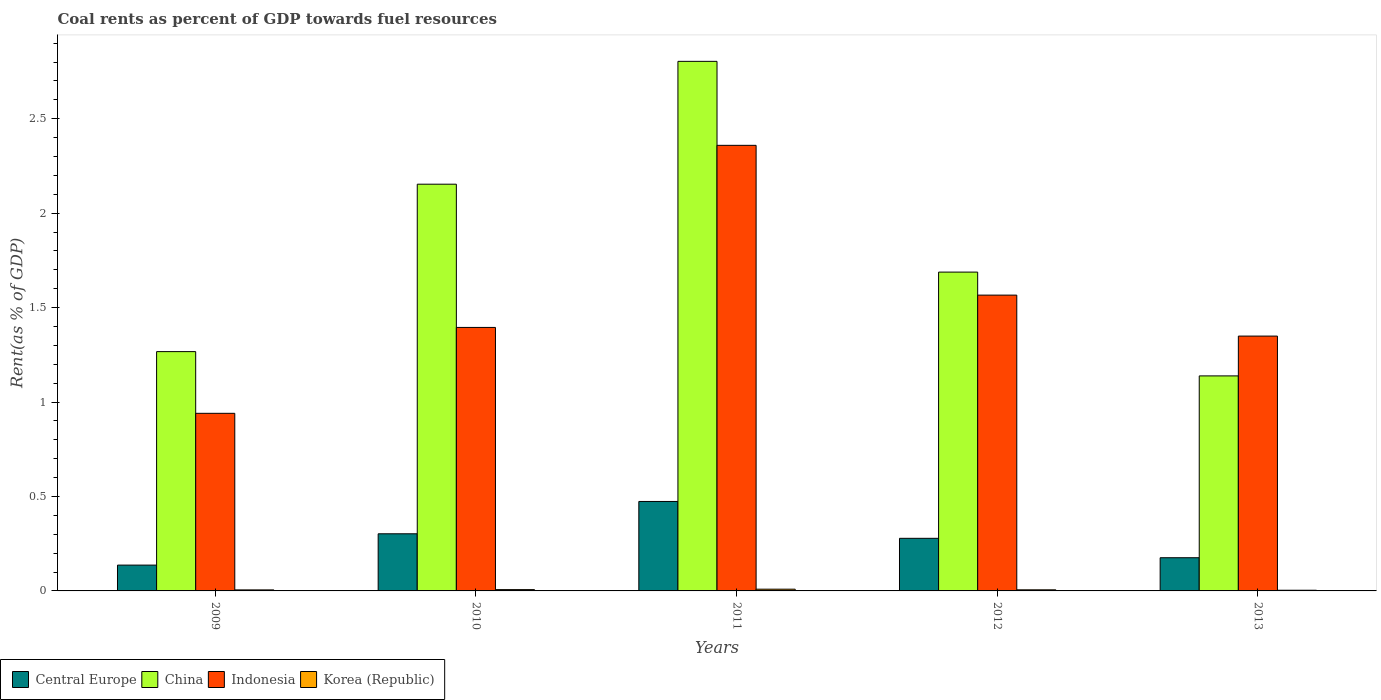How many different coloured bars are there?
Make the answer very short. 4. Are the number of bars per tick equal to the number of legend labels?
Offer a very short reply. Yes. How many bars are there on the 1st tick from the right?
Make the answer very short. 4. What is the label of the 1st group of bars from the left?
Provide a succinct answer. 2009. What is the coal rent in Indonesia in 2013?
Offer a very short reply. 1.35. Across all years, what is the maximum coal rent in China?
Your answer should be compact. 2.8. Across all years, what is the minimum coal rent in Indonesia?
Make the answer very short. 0.94. In which year was the coal rent in Indonesia minimum?
Make the answer very short. 2009. What is the total coal rent in China in the graph?
Offer a terse response. 9.05. What is the difference between the coal rent in Korea (Republic) in 2009 and that in 2013?
Your response must be concise. 0. What is the difference between the coal rent in China in 2010 and the coal rent in Korea (Republic) in 2013?
Make the answer very short. 2.15. What is the average coal rent in Indonesia per year?
Make the answer very short. 1.52. In the year 2010, what is the difference between the coal rent in China and coal rent in Korea (Republic)?
Offer a very short reply. 2.15. In how many years, is the coal rent in China greater than 1.1 %?
Your answer should be compact. 5. What is the ratio of the coal rent in Central Europe in 2011 to that in 2012?
Make the answer very short. 1.7. Is the coal rent in Central Europe in 2009 less than that in 2011?
Make the answer very short. Yes. What is the difference between the highest and the second highest coal rent in China?
Keep it short and to the point. 0.65. What is the difference between the highest and the lowest coal rent in Central Europe?
Give a very brief answer. 0.34. Is the sum of the coal rent in Indonesia in 2010 and 2012 greater than the maximum coal rent in Central Europe across all years?
Provide a short and direct response. Yes. Is it the case that in every year, the sum of the coal rent in Indonesia and coal rent in China is greater than the sum of coal rent in Korea (Republic) and coal rent in Central Europe?
Offer a terse response. Yes. What does the 2nd bar from the right in 2012 represents?
Give a very brief answer. Indonesia. Is it the case that in every year, the sum of the coal rent in Central Europe and coal rent in Korea (Republic) is greater than the coal rent in China?
Offer a very short reply. No. Are all the bars in the graph horizontal?
Your response must be concise. No. What is the difference between two consecutive major ticks on the Y-axis?
Offer a very short reply. 0.5. Are the values on the major ticks of Y-axis written in scientific E-notation?
Ensure brevity in your answer.  No. Does the graph contain grids?
Provide a short and direct response. No. Where does the legend appear in the graph?
Give a very brief answer. Bottom left. How many legend labels are there?
Make the answer very short. 4. How are the legend labels stacked?
Keep it short and to the point. Horizontal. What is the title of the graph?
Your answer should be compact. Coal rents as percent of GDP towards fuel resources. What is the label or title of the X-axis?
Your answer should be compact. Years. What is the label or title of the Y-axis?
Provide a short and direct response. Rent(as % of GDP). What is the Rent(as % of GDP) in Central Europe in 2009?
Provide a short and direct response. 0.14. What is the Rent(as % of GDP) in China in 2009?
Make the answer very short. 1.27. What is the Rent(as % of GDP) of Indonesia in 2009?
Keep it short and to the point. 0.94. What is the Rent(as % of GDP) in Korea (Republic) in 2009?
Give a very brief answer. 0.01. What is the Rent(as % of GDP) in Central Europe in 2010?
Provide a succinct answer. 0.3. What is the Rent(as % of GDP) of China in 2010?
Keep it short and to the point. 2.15. What is the Rent(as % of GDP) of Indonesia in 2010?
Offer a very short reply. 1.39. What is the Rent(as % of GDP) of Korea (Republic) in 2010?
Ensure brevity in your answer.  0.01. What is the Rent(as % of GDP) of Central Europe in 2011?
Offer a terse response. 0.47. What is the Rent(as % of GDP) in China in 2011?
Offer a very short reply. 2.8. What is the Rent(as % of GDP) in Indonesia in 2011?
Your answer should be compact. 2.36. What is the Rent(as % of GDP) in Korea (Republic) in 2011?
Your response must be concise. 0.01. What is the Rent(as % of GDP) of Central Europe in 2012?
Your response must be concise. 0.28. What is the Rent(as % of GDP) of China in 2012?
Offer a very short reply. 1.69. What is the Rent(as % of GDP) of Indonesia in 2012?
Provide a short and direct response. 1.57. What is the Rent(as % of GDP) of Korea (Republic) in 2012?
Provide a succinct answer. 0.01. What is the Rent(as % of GDP) in Central Europe in 2013?
Ensure brevity in your answer.  0.18. What is the Rent(as % of GDP) in China in 2013?
Make the answer very short. 1.14. What is the Rent(as % of GDP) of Indonesia in 2013?
Your answer should be compact. 1.35. What is the Rent(as % of GDP) of Korea (Republic) in 2013?
Provide a succinct answer. 0. Across all years, what is the maximum Rent(as % of GDP) in Central Europe?
Your answer should be very brief. 0.47. Across all years, what is the maximum Rent(as % of GDP) in China?
Provide a short and direct response. 2.8. Across all years, what is the maximum Rent(as % of GDP) of Indonesia?
Offer a very short reply. 2.36. Across all years, what is the maximum Rent(as % of GDP) in Korea (Republic)?
Provide a succinct answer. 0.01. Across all years, what is the minimum Rent(as % of GDP) in Central Europe?
Offer a very short reply. 0.14. Across all years, what is the minimum Rent(as % of GDP) of China?
Keep it short and to the point. 1.14. Across all years, what is the minimum Rent(as % of GDP) in Indonesia?
Make the answer very short. 0.94. Across all years, what is the minimum Rent(as % of GDP) in Korea (Republic)?
Your answer should be compact. 0. What is the total Rent(as % of GDP) in Central Europe in the graph?
Keep it short and to the point. 1.37. What is the total Rent(as % of GDP) of China in the graph?
Provide a succinct answer. 9.05. What is the total Rent(as % of GDP) in Indonesia in the graph?
Provide a succinct answer. 7.61. What is the total Rent(as % of GDP) of Korea (Republic) in the graph?
Provide a short and direct response. 0.03. What is the difference between the Rent(as % of GDP) in Central Europe in 2009 and that in 2010?
Keep it short and to the point. -0.17. What is the difference between the Rent(as % of GDP) of China in 2009 and that in 2010?
Provide a short and direct response. -0.89. What is the difference between the Rent(as % of GDP) in Indonesia in 2009 and that in 2010?
Give a very brief answer. -0.45. What is the difference between the Rent(as % of GDP) of Korea (Republic) in 2009 and that in 2010?
Provide a succinct answer. -0. What is the difference between the Rent(as % of GDP) of Central Europe in 2009 and that in 2011?
Your response must be concise. -0.34. What is the difference between the Rent(as % of GDP) in China in 2009 and that in 2011?
Your answer should be very brief. -1.54. What is the difference between the Rent(as % of GDP) of Indonesia in 2009 and that in 2011?
Make the answer very short. -1.42. What is the difference between the Rent(as % of GDP) in Korea (Republic) in 2009 and that in 2011?
Your answer should be very brief. -0. What is the difference between the Rent(as % of GDP) in Central Europe in 2009 and that in 2012?
Provide a succinct answer. -0.14. What is the difference between the Rent(as % of GDP) of China in 2009 and that in 2012?
Your answer should be compact. -0.42. What is the difference between the Rent(as % of GDP) of Indonesia in 2009 and that in 2012?
Make the answer very short. -0.63. What is the difference between the Rent(as % of GDP) of Korea (Republic) in 2009 and that in 2012?
Offer a terse response. -0. What is the difference between the Rent(as % of GDP) of Central Europe in 2009 and that in 2013?
Your answer should be very brief. -0.04. What is the difference between the Rent(as % of GDP) in China in 2009 and that in 2013?
Ensure brevity in your answer.  0.13. What is the difference between the Rent(as % of GDP) in Indonesia in 2009 and that in 2013?
Keep it short and to the point. -0.41. What is the difference between the Rent(as % of GDP) of Korea (Republic) in 2009 and that in 2013?
Offer a very short reply. 0. What is the difference between the Rent(as % of GDP) in Central Europe in 2010 and that in 2011?
Provide a short and direct response. -0.17. What is the difference between the Rent(as % of GDP) of China in 2010 and that in 2011?
Offer a very short reply. -0.65. What is the difference between the Rent(as % of GDP) in Indonesia in 2010 and that in 2011?
Your answer should be compact. -0.96. What is the difference between the Rent(as % of GDP) in Korea (Republic) in 2010 and that in 2011?
Your answer should be compact. -0. What is the difference between the Rent(as % of GDP) in Central Europe in 2010 and that in 2012?
Make the answer very short. 0.02. What is the difference between the Rent(as % of GDP) of China in 2010 and that in 2012?
Offer a very short reply. 0.47. What is the difference between the Rent(as % of GDP) in Indonesia in 2010 and that in 2012?
Ensure brevity in your answer.  -0.17. What is the difference between the Rent(as % of GDP) in Korea (Republic) in 2010 and that in 2012?
Provide a succinct answer. 0. What is the difference between the Rent(as % of GDP) in Central Europe in 2010 and that in 2013?
Offer a terse response. 0.13. What is the difference between the Rent(as % of GDP) in China in 2010 and that in 2013?
Give a very brief answer. 1.01. What is the difference between the Rent(as % of GDP) of Indonesia in 2010 and that in 2013?
Keep it short and to the point. 0.05. What is the difference between the Rent(as % of GDP) in Korea (Republic) in 2010 and that in 2013?
Offer a very short reply. 0. What is the difference between the Rent(as % of GDP) in Central Europe in 2011 and that in 2012?
Your response must be concise. 0.2. What is the difference between the Rent(as % of GDP) of China in 2011 and that in 2012?
Ensure brevity in your answer.  1.12. What is the difference between the Rent(as % of GDP) in Indonesia in 2011 and that in 2012?
Provide a succinct answer. 0.79. What is the difference between the Rent(as % of GDP) in Korea (Republic) in 2011 and that in 2012?
Offer a terse response. 0. What is the difference between the Rent(as % of GDP) of Central Europe in 2011 and that in 2013?
Provide a short and direct response. 0.3. What is the difference between the Rent(as % of GDP) of China in 2011 and that in 2013?
Your answer should be compact. 1.67. What is the difference between the Rent(as % of GDP) in Indonesia in 2011 and that in 2013?
Offer a very short reply. 1.01. What is the difference between the Rent(as % of GDP) of Korea (Republic) in 2011 and that in 2013?
Provide a succinct answer. 0.01. What is the difference between the Rent(as % of GDP) in Central Europe in 2012 and that in 2013?
Make the answer very short. 0.1. What is the difference between the Rent(as % of GDP) of China in 2012 and that in 2013?
Provide a short and direct response. 0.55. What is the difference between the Rent(as % of GDP) in Indonesia in 2012 and that in 2013?
Offer a terse response. 0.22. What is the difference between the Rent(as % of GDP) of Korea (Republic) in 2012 and that in 2013?
Make the answer very short. 0. What is the difference between the Rent(as % of GDP) of Central Europe in 2009 and the Rent(as % of GDP) of China in 2010?
Ensure brevity in your answer.  -2.02. What is the difference between the Rent(as % of GDP) in Central Europe in 2009 and the Rent(as % of GDP) in Indonesia in 2010?
Your response must be concise. -1.26. What is the difference between the Rent(as % of GDP) in Central Europe in 2009 and the Rent(as % of GDP) in Korea (Republic) in 2010?
Provide a succinct answer. 0.13. What is the difference between the Rent(as % of GDP) in China in 2009 and the Rent(as % of GDP) in Indonesia in 2010?
Provide a succinct answer. -0.13. What is the difference between the Rent(as % of GDP) of China in 2009 and the Rent(as % of GDP) of Korea (Republic) in 2010?
Your answer should be compact. 1.26. What is the difference between the Rent(as % of GDP) of Indonesia in 2009 and the Rent(as % of GDP) of Korea (Republic) in 2010?
Your response must be concise. 0.93. What is the difference between the Rent(as % of GDP) of Central Europe in 2009 and the Rent(as % of GDP) of China in 2011?
Make the answer very short. -2.67. What is the difference between the Rent(as % of GDP) of Central Europe in 2009 and the Rent(as % of GDP) of Indonesia in 2011?
Keep it short and to the point. -2.22. What is the difference between the Rent(as % of GDP) in Central Europe in 2009 and the Rent(as % of GDP) in Korea (Republic) in 2011?
Your response must be concise. 0.13. What is the difference between the Rent(as % of GDP) in China in 2009 and the Rent(as % of GDP) in Indonesia in 2011?
Your answer should be very brief. -1.09. What is the difference between the Rent(as % of GDP) of China in 2009 and the Rent(as % of GDP) of Korea (Republic) in 2011?
Offer a terse response. 1.26. What is the difference between the Rent(as % of GDP) of Indonesia in 2009 and the Rent(as % of GDP) of Korea (Republic) in 2011?
Give a very brief answer. 0.93. What is the difference between the Rent(as % of GDP) of Central Europe in 2009 and the Rent(as % of GDP) of China in 2012?
Give a very brief answer. -1.55. What is the difference between the Rent(as % of GDP) in Central Europe in 2009 and the Rent(as % of GDP) in Indonesia in 2012?
Keep it short and to the point. -1.43. What is the difference between the Rent(as % of GDP) of Central Europe in 2009 and the Rent(as % of GDP) of Korea (Republic) in 2012?
Your response must be concise. 0.13. What is the difference between the Rent(as % of GDP) in China in 2009 and the Rent(as % of GDP) in Indonesia in 2012?
Ensure brevity in your answer.  -0.3. What is the difference between the Rent(as % of GDP) of China in 2009 and the Rent(as % of GDP) of Korea (Republic) in 2012?
Your answer should be compact. 1.26. What is the difference between the Rent(as % of GDP) of Indonesia in 2009 and the Rent(as % of GDP) of Korea (Republic) in 2012?
Your response must be concise. 0.93. What is the difference between the Rent(as % of GDP) in Central Europe in 2009 and the Rent(as % of GDP) in China in 2013?
Provide a short and direct response. -1. What is the difference between the Rent(as % of GDP) of Central Europe in 2009 and the Rent(as % of GDP) of Indonesia in 2013?
Offer a terse response. -1.21. What is the difference between the Rent(as % of GDP) in Central Europe in 2009 and the Rent(as % of GDP) in Korea (Republic) in 2013?
Your response must be concise. 0.13. What is the difference between the Rent(as % of GDP) in China in 2009 and the Rent(as % of GDP) in Indonesia in 2013?
Provide a short and direct response. -0.08. What is the difference between the Rent(as % of GDP) of China in 2009 and the Rent(as % of GDP) of Korea (Republic) in 2013?
Make the answer very short. 1.26. What is the difference between the Rent(as % of GDP) in Indonesia in 2009 and the Rent(as % of GDP) in Korea (Republic) in 2013?
Offer a terse response. 0.94. What is the difference between the Rent(as % of GDP) of Central Europe in 2010 and the Rent(as % of GDP) of China in 2011?
Your response must be concise. -2.5. What is the difference between the Rent(as % of GDP) of Central Europe in 2010 and the Rent(as % of GDP) of Indonesia in 2011?
Ensure brevity in your answer.  -2.06. What is the difference between the Rent(as % of GDP) in Central Europe in 2010 and the Rent(as % of GDP) in Korea (Republic) in 2011?
Your answer should be very brief. 0.29. What is the difference between the Rent(as % of GDP) of China in 2010 and the Rent(as % of GDP) of Indonesia in 2011?
Make the answer very short. -0.21. What is the difference between the Rent(as % of GDP) of China in 2010 and the Rent(as % of GDP) of Korea (Republic) in 2011?
Your answer should be compact. 2.14. What is the difference between the Rent(as % of GDP) of Indonesia in 2010 and the Rent(as % of GDP) of Korea (Republic) in 2011?
Provide a succinct answer. 1.39. What is the difference between the Rent(as % of GDP) of Central Europe in 2010 and the Rent(as % of GDP) of China in 2012?
Offer a very short reply. -1.39. What is the difference between the Rent(as % of GDP) of Central Europe in 2010 and the Rent(as % of GDP) of Indonesia in 2012?
Your answer should be very brief. -1.26. What is the difference between the Rent(as % of GDP) of Central Europe in 2010 and the Rent(as % of GDP) of Korea (Republic) in 2012?
Your response must be concise. 0.3. What is the difference between the Rent(as % of GDP) in China in 2010 and the Rent(as % of GDP) in Indonesia in 2012?
Ensure brevity in your answer.  0.59. What is the difference between the Rent(as % of GDP) of China in 2010 and the Rent(as % of GDP) of Korea (Republic) in 2012?
Your answer should be compact. 2.15. What is the difference between the Rent(as % of GDP) of Indonesia in 2010 and the Rent(as % of GDP) of Korea (Republic) in 2012?
Your answer should be very brief. 1.39. What is the difference between the Rent(as % of GDP) of Central Europe in 2010 and the Rent(as % of GDP) of China in 2013?
Provide a succinct answer. -0.84. What is the difference between the Rent(as % of GDP) in Central Europe in 2010 and the Rent(as % of GDP) in Indonesia in 2013?
Offer a very short reply. -1.05. What is the difference between the Rent(as % of GDP) of Central Europe in 2010 and the Rent(as % of GDP) of Korea (Republic) in 2013?
Ensure brevity in your answer.  0.3. What is the difference between the Rent(as % of GDP) of China in 2010 and the Rent(as % of GDP) of Indonesia in 2013?
Give a very brief answer. 0.8. What is the difference between the Rent(as % of GDP) of China in 2010 and the Rent(as % of GDP) of Korea (Republic) in 2013?
Make the answer very short. 2.15. What is the difference between the Rent(as % of GDP) of Indonesia in 2010 and the Rent(as % of GDP) of Korea (Republic) in 2013?
Offer a very short reply. 1.39. What is the difference between the Rent(as % of GDP) in Central Europe in 2011 and the Rent(as % of GDP) in China in 2012?
Make the answer very short. -1.21. What is the difference between the Rent(as % of GDP) of Central Europe in 2011 and the Rent(as % of GDP) of Indonesia in 2012?
Ensure brevity in your answer.  -1.09. What is the difference between the Rent(as % of GDP) in Central Europe in 2011 and the Rent(as % of GDP) in Korea (Republic) in 2012?
Provide a short and direct response. 0.47. What is the difference between the Rent(as % of GDP) in China in 2011 and the Rent(as % of GDP) in Indonesia in 2012?
Your answer should be very brief. 1.24. What is the difference between the Rent(as % of GDP) of China in 2011 and the Rent(as % of GDP) of Korea (Republic) in 2012?
Offer a very short reply. 2.8. What is the difference between the Rent(as % of GDP) of Indonesia in 2011 and the Rent(as % of GDP) of Korea (Republic) in 2012?
Make the answer very short. 2.35. What is the difference between the Rent(as % of GDP) in Central Europe in 2011 and the Rent(as % of GDP) in China in 2013?
Provide a succinct answer. -0.66. What is the difference between the Rent(as % of GDP) of Central Europe in 2011 and the Rent(as % of GDP) of Indonesia in 2013?
Offer a very short reply. -0.88. What is the difference between the Rent(as % of GDP) of Central Europe in 2011 and the Rent(as % of GDP) of Korea (Republic) in 2013?
Ensure brevity in your answer.  0.47. What is the difference between the Rent(as % of GDP) in China in 2011 and the Rent(as % of GDP) in Indonesia in 2013?
Provide a succinct answer. 1.45. What is the difference between the Rent(as % of GDP) in China in 2011 and the Rent(as % of GDP) in Korea (Republic) in 2013?
Provide a succinct answer. 2.8. What is the difference between the Rent(as % of GDP) of Indonesia in 2011 and the Rent(as % of GDP) of Korea (Republic) in 2013?
Provide a short and direct response. 2.36. What is the difference between the Rent(as % of GDP) of Central Europe in 2012 and the Rent(as % of GDP) of China in 2013?
Keep it short and to the point. -0.86. What is the difference between the Rent(as % of GDP) of Central Europe in 2012 and the Rent(as % of GDP) of Indonesia in 2013?
Offer a very short reply. -1.07. What is the difference between the Rent(as % of GDP) of Central Europe in 2012 and the Rent(as % of GDP) of Korea (Republic) in 2013?
Provide a short and direct response. 0.27. What is the difference between the Rent(as % of GDP) in China in 2012 and the Rent(as % of GDP) in Indonesia in 2013?
Provide a succinct answer. 0.34. What is the difference between the Rent(as % of GDP) of China in 2012 and the Rent(as % of GDP) of Korea (Republic) in 2013?
Offer a terse response. 1.68. What is the difference between the Rent(as % of GDP) in Indonesia in 2012 and the Rent(as % of GDP) in Korea (Republic) in 2013?
Your answer should be very brief. 1.56. What is the average Rent(as % of GDP) of Central Europe per year?
Your answer should be compact. 0.27. What is the average Rent(as % of GDP) in China per year?
Make the answer very short. 1.81. What is the average Rent(as % of GDP) of Indonesia per year?
Your response must be concise. 1.52. What is the average Rent(as % of GDP) in Korea (Republic) per year?
Your answer should be compact. 0.01. In the year 2009, what is the difference between the Rent(as % of GDP) of Central Europe and Rent(as % of GDP) of China?
Keep it short and to the point. -1.13. In the year 2009, what is the difference between the Rent(as % of GDP) in Central Europe and Rent(as % of GDP) in Indonesia?
Offer a terse response. -0.8. In the year 2009, what is the difference between the Rent(as % of GDP) of Central Europe and Rent(as % of GDP) of Korea (Republic)?
Make the answer very short. 0.13. In the year 2009, what is the difference between the Rent(as % of GDP) of China and Rent(as % of GDP) of Indonesia?
Offer a very short reply. 0.33. In the year 2009, what is the difference between the Rent(as % of GDP) of China and Rent(as % of GDP) of Korea (Republic)?
Offer a very short reply. 1.26. In the year 2009, what is the difference between the Rent(as % of GDP) of Indonesia and Rent(as % of GDP) of Korea (Republic)?
Your answer should be very brief. 0.93. In the year 2010, what is the difference between the Rent(as % of GDP) in Central Europe and Rent(as % of GDP) in China?
Provide a short and direct response. -1.85. In the year 2010, what is the difference between the Rent(as % of GDP) of Central Europe and Rent(as % of GDP) of Indonesia?
Offer a very short reply. -1.09. In the year 2010, what is the difference between the Rent(as % of GDP) of Central Europe and Rent(as % of GDP) of Korea (Republic)?
Your answer should be compact. 0.3. In the year 2010, what is the difference between the Rent(as % of GDP) of China and Rent(as % of GDP) of Indonesia?
Keep it short and to the point. 0.76. In the year 2010, what is the difference between the Rent(as % of GDP) in China and Rent(as % of GDP) in Korea (Republic)?
Offer a terse response. 2.15. In the year 2010, what is the difference between the Rent(as % of GDP) of Indonesia and Rent(as % of GDP) of Korea (Republic)?
Make the answer very short. 1.39. In the year 2011, what is the difference between the Rent(as % of GDP) of Central Europe and Rent(as % of GDP) of China?
Provide a short and direct response. -2.33. In the year 2011, what is the difference between the Rent(as % of GDP) of Central Europe and Rent(as % of GDP) of Indonesia?
Your answer should be compact. -1.89. In the year 2011, what is the difference between the Rent(as % of GDP) of Central Europe and Rent(as % of GDP) of Korea (Republic)?
Give a very brief answer. 0.46. In the year 2011, what is the difference between the Rent(as % of GDP) of China and Rent(as % of GDP) of Indonesia?
Provide a short and direct response. 0.44. In the year 2011, what is the difference between the Rent(as % of GDP) in China and Rent(as % of GDP) in Korea (Republic)?
Make the answer very short. 2.79. In the year 2011, what is the difference between the Rent(as % of GDP) in Indonesia and Rent(as % of GDP) in Korea (Republic)?
Your answer should be very brief. 2.35. In the year 2012, what is the difference between the Rent(as % of GDP) in Central Europe and Rent(as % of GDP) in China?
Offer a very short reply. -1.41. In the year 2012, what is the difference between the Rent(as % of GDP) of Central Europe and Rent(as % of GDP) of Indonesia?
Your response must be concise. -1.29. In the year 2012, what is the difference between the Rent(as % of GDP) in Central Europe and Rent(as % of GDP) in Korea (Republic)?
Offer a very short reply. 0.27. In the year 2012, what is the difference between the Rent(as % of GDP) in China and Rent(as % of GDP) in Indonesia?
Keep it short and to the point. 0.12. In the year 2012, what is the difference between the Rent(as % of GDP) in China and Rent(as % of GDP) in Korea (Republic)?
Give a very brief answer. 1.68. In the year 2012, what is the difference between the Rent(as % of GDP) of Indonesia and Rent(as % of GDP) of Korea (Republic)?
Provide a short and direct response. 1.56. In the year 2013, what is the difference between the Rent(as % of GDP) in Central Europe and Rent(as % of GDP) in China?
Make the answer very short. -0.96. In the year 2013, what is the difference between the Rent(as % of GDP) in Central Europe and Rent(as % of GDP) in Indonesia?
Give a very brief answer. -1.17. In the year 2013, what is the difference between the Rent(as % of GDP) of Central Europe and Rent(as % of GDP) of Korea (Republic)?
Provide a succinct answer. 0.17. In the year 2013, what is the difference between the Rent(as % of GDP) in China and Rent(as % of GDP) in Indonesia?
Offer a terse response. -0.21. In the year 2013, what is the difference between the Rent(as % of GDP) in China and Rent(as % of GDP) in Korea (Republic)?
Offer a terse response. 1.13. In the year 2013, what is the difference between the Rent(as % of GDP) in Indonesia and Rent(as % of GDP) in Korea (Republic)?
Your response must be concise. 1.35. What is the ratio of the Rent(as % of GDP) in Central Europe in 2009 to that in 2010?
Your response must be concise. 0.45. What is the ratio of the Rent(as % of GDP) in China in 2009 to that in 2010?
Offer a terse response. 0.59. What is the ratio of the Rent(as % of GDP) in Indonesia in 2009 to that in 2010?
Your answer should be compact. 0.67. What is the ratio of the Rent(as % of GDP) in Korea (Republic) in 2009 to that in 2010?
Your response must be concise. 0.78. What is the ratio of the Rent(as % of GDP) in Central Europe in 2009 to that in 2011?
Provide a succinct answer. 0.29. What is the ratio of the Rent(as % of GDP) in China in 2009 to that in 2011?
Your answer should be very brief. 0.45. What is the ratio of the Rent(as % of GDP) in Indonesia in 2009 to that in 2011?
Your answer should be very brief. 0.4. What is the ratio of the Rent(as % of GDP) in Korea (Republic) in 2009 to that in 2011?
Ensure brevity in your answer.  0.58. What is the ratio of the Rent(as % of GDP) of Central Europe in 2009 to that in 2012?
Offer a very short reply. 0.49. What is the ratio of the Rent(as % of GDP) in China in 2009 to that in 2012?
Your answer should be compact. 0.75. What is the ratio of the Rent(as % of GDP) in Indonesia in 2009 to that in 2012?
Provide a succinct answer. 0.6. What is the ratio of the Rent(as % of GDP) in Korea (Republic) in 2009 to that in 2012?
Your answer should be very brief. 0.93. What is the ratio of the Rent(as % of GDP) in Central Europe in 2009 to that in 2013?
Make the answer very short. 0.78. What is the ratio of the Rent(as % of GDP) of China in 2009 to that in 2013?
Your answer should be very brief. 1.11. What is the ratio of the Rent(as % of GDP) in Indonesia in 2009 to that in 2013?
Ensure brevity in your answer.  0.7. What is the ratio of the Rent(as % of GDP) of Korea (Republic) in 2009 to that in 2013?
Your answer should be compact. 1.52. What is the ratio of the Rent(as % of GDP) of Central Europe in 2010 to that in 2011?
Offer a very short reply. 0.64. What is the ratio of the Rent(as % of GDP) of China in 2010 to that in 2011?
Your answer should be very brief. 0.77. What is the ratio of the Rent(as % of GDP) of Indonesia in 2010 to that in 2011?
Your response must be concise. 0.59. What is the ratio of the Rent(as % of GDP) of Korea (Republic) in 2010 to that in 2011?
Provide a succinct answer. 0.75. What is the ratio of the Rent(as % of GDP) in Central Europe in 2010 to that in 2012?
Keep it short and to the point. 1.09. What is the ratio of the Rent(as % of GDP) in China in 2010 to that in 2012?
Offer a very short reply. 1.28. What is the ratio of the Rent(as % of GDP) in Indonesia in 2010 to that in 2012?
Ensure brevity in your answer.  0.89. What is the ratio of the Rent(as % of GDP) of Korea (Republic) in 2010 to that in 2012?
Make the answer very short. 1.19. What is the ratio of the Rent(as % of GDP) of Central Europe in 2010 to that in 2013?
Your response must be concise. 1.72. What is the ratio of the Rent(as % of GDP) of China in 2010 to that in 2013?
Give a very brief answer. 1.89. What is the ratio of the Rent(as % of GDP) of Indonesia in 2010 to that in 2013?
Ensure brevity in your answer.  1.03. What is the ratio of the Rent(as % of GDP) in Korea (Republic) in 2010 to that in 2013?
Your answer should be very brief. 1.93. What is the ratio of the Rent(as % of GDP) of Central Europe in 2011 to that in 2012?
Keep it short and to the point. 1.7. What is the ratio of the Rent(as % of GDP) in China in 2011 to that in 2012?
Provide a short and direct response. 1.66. What is the ratio of the Rent(as % of GDP) in Indonesia in 2011 to that in 2012?
Keep it short and to the point. 1.51. What is the ratio of the Rent(as % of GDP) in Korea (Republic) in 2011 to that in 2012?
Your answer should be compact. 1.59. What is the ratio of the Rent(as % of GDP) in Central Europe in 2011 to that in 2013?
Ensure brevity in your answer.  2.69. What is the ratio of the Rent(as % of GDP) in China in 2011 to that in 2013?
Offer a very short reply. 2.46. What is the ratio of the Rent(as % of GDP) in Indonesia in 2011 to that in 2013?
Keep it short and to the point. 1.75. What is the ratio of the Rent(as % of GDP) in Korea (Republic) in 2011 to that in 2013?
Make the answer very short. 2.59. What is the ratio of the Rent(as % of GDP) of Central Europe in 2012 to that in 2013?
Offer a terse response. 1.58. What is the ratio of the Rent(as % of GDP) of China in 2012 to that in 2013?
Ensure brevity in your answer.  1.48. What is the ratio of the Rent(as % of GDP) of Indonesia in 2012 to that in 2013?
Ensure brevity in your answer.  1.16. What is the ratio of the Rent(as % of GDP) in Korea (Republic) in 2012 to that in 2013?
Give a very brief answer. 1.63. What is the difference between the highest and the second highest Rent(as % of GDP) in Central Europe?
Your answer should be compact. 0.17. What is the difference between the highest and the second highest Rent(as % of GDP) in China?
Offer a very short reply. 0.65. What is the difference between the highest and the second highest Rent(as % of GDP) of Indonesia?
Provide a short and direct response. 0.79. What is the difference between the highest and the second highest Rent(as % of GDP) of Korea (Republic)?
Ensure brevity in your answer.  0. What is the difference between the highest and the lowest Rent(as % of GDP) in Central Europe?
Ensure brevity in your answer.  0.34. What is the difference between the highest and the lowest Rent(as % of GDP) of China?
Keep it short and to the point. 1.67. What is the difference between the highest and the lowest Rent(as % of GDP) of Indonesia?
Your answer should be very brief. 1.42. What is the difference between the highest and the lowest Rent(as % of GDP) of Korea (Republic)?
Keep it short and to the point. 0.01. 